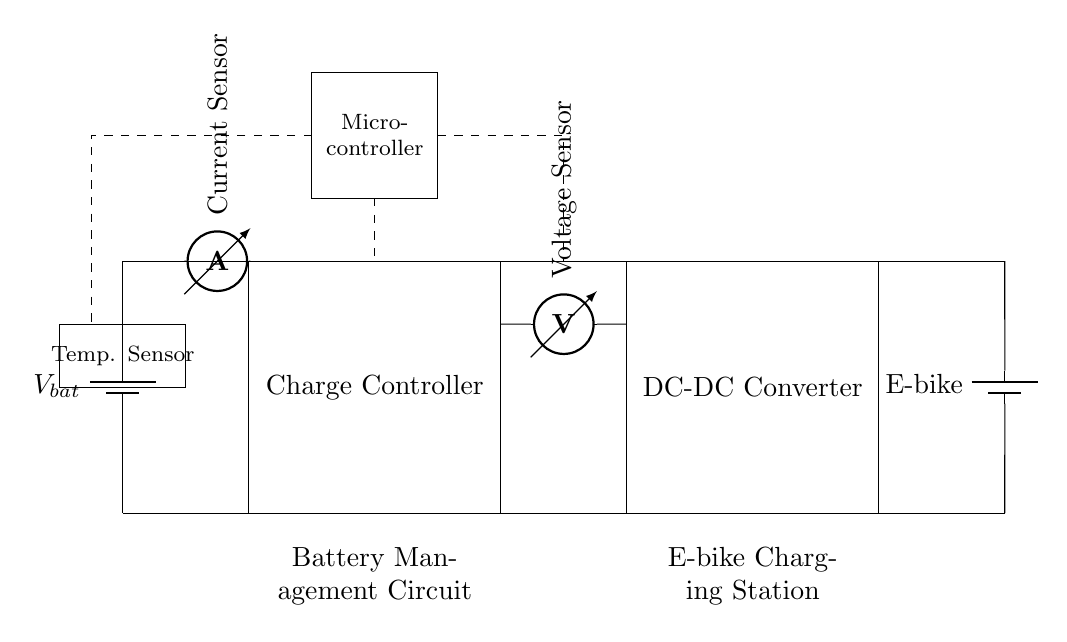What is the main component for charging the battery? The charge controller is the main component responsible for managing the charging of the battery in this circuit. It is critical for ensuring that the battery is charged efficiently and safely.
Answer: Charge Controller What does the current sensor measure? The current sensor is positioned in line with the battery and the charge controller, indicating that it measures the current flowing into the battery during the charging process. This is essential for monitoring the charging status and protecting the battery.
Answer: Current Which component regulates the output voltage to the e-bike? The DC-DC converter is the component responsible for regulating the output voltage to the e-bike. It transforms the input voltage to match the specific requirements of the e-bike's battery.
Answer: DC-DC Converter What is the purpose of the temperature sensor? The temperature sensor is included to monitor the temperature of the battery. High temperatures can be harmful to battery health, so having a sensor allows for monitoring and potential safety measures to prevent overheating.
Answer: Monitor battery temperature How does this circuit ensure battery safety? The circuit ensures battery safety through the use of multiple sensors, including the current sensor and temperature sensor, combined with a microcontroller that processes this information to manage charging and prevent unsafe conditions.
Answer: Through sensors and microcontroller What type of appliance is this circuit designed for? This circuit is designed specifically for an e-bike charging station. The configuration and components reflect its purpose in managing the charging of e-bike batteries.
Answer: E-bike Charging Station 